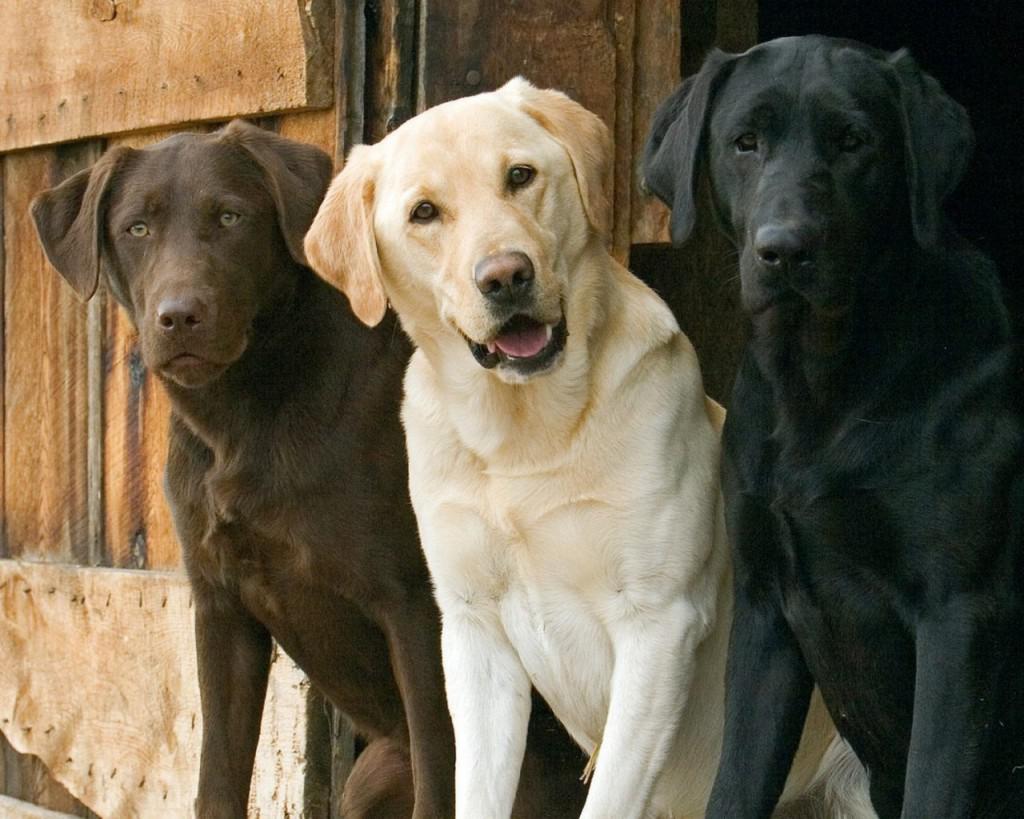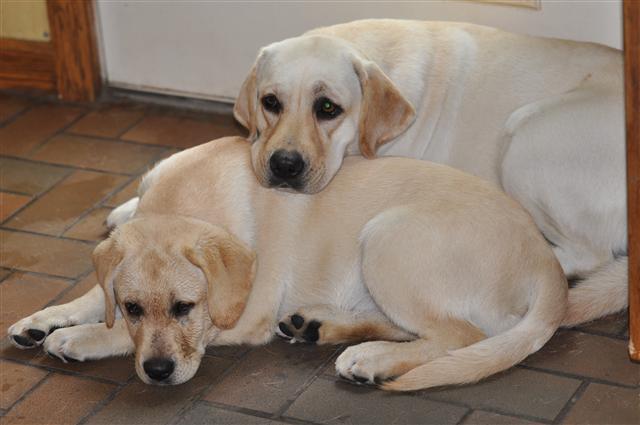The first image is the image on the left, the second image is the image on the right. Considering the images on both sides, is "One image shows exactly three dogs, each a different color." valid? Answer yes or no. Yes. 